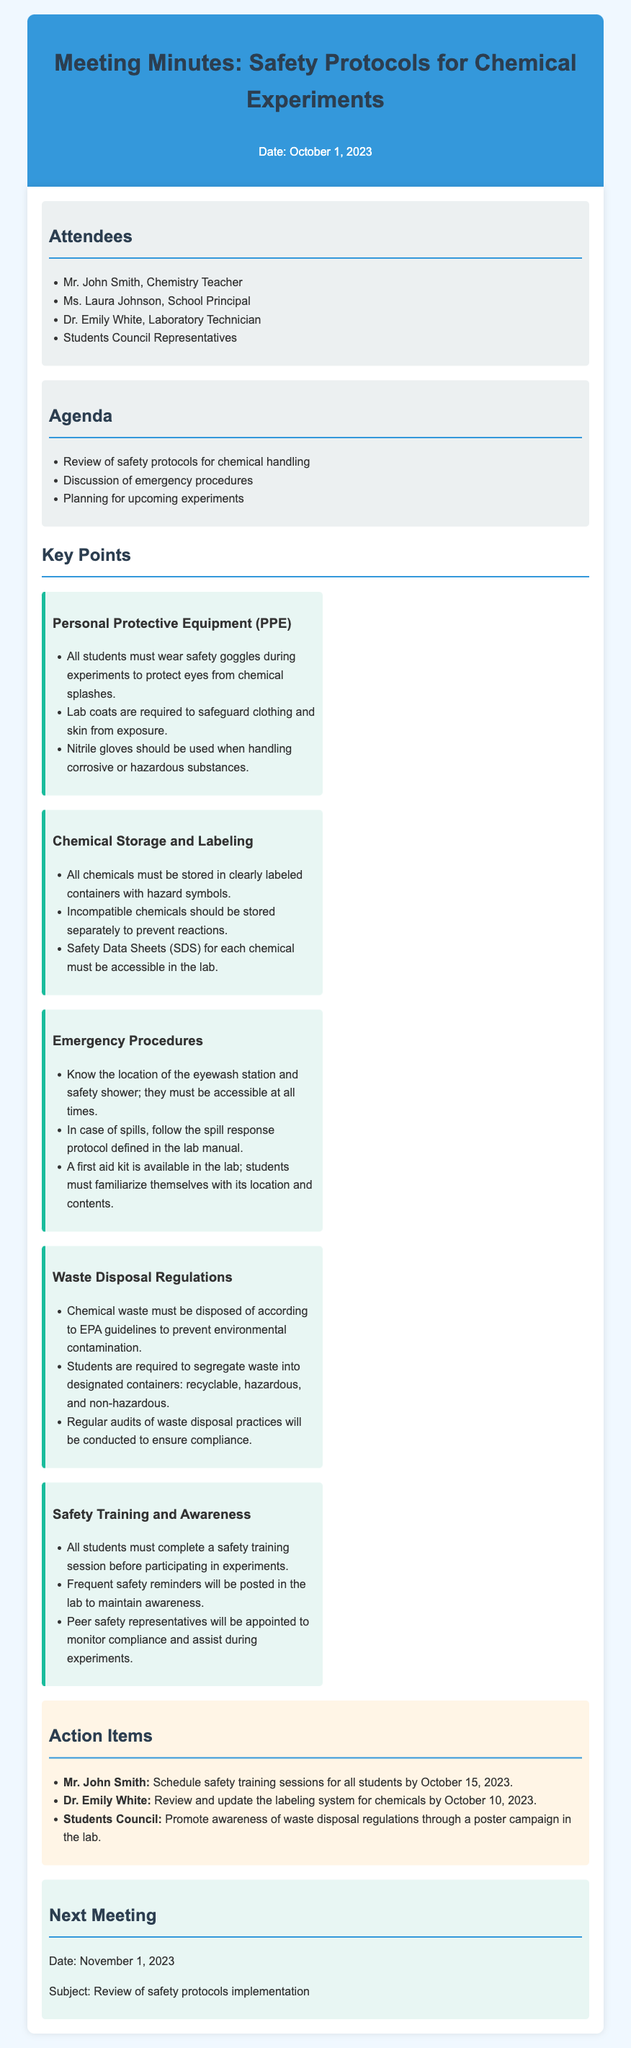What is the date of the meeting? The meeting date is stated in the document header.
Answer: October 1, 2023 Who is the chemistry teacher mentioned? Mr. John Smith is listed as the chemistry teacher in the attendees section.
Answer: Mr. John Smith What equipment must students wear during experiments? The key points outline the personal protective equipment needed.
Answer: Safety goggles What must be accessible in the lab according to the emergency procedures? The key points specify where students should know the location of during emergencies.
Answer: Eyewash station What are students required to complete before participating in experiments? The safety training and awareness section indicates what is mandatory for students.
Answer: Safety training session When is the next meeting scheduled? The next meeting date is mentioned towards the end of the document.
Answer: November 1, 2023 Who is responsible for reviewing the labeling system for chemicals? The action items list specifies who will update the labeling system.
Answer: Dr. Emily White What must chemical waste be disposed of according to? The waste disposal regulations section specifies the guidelines for disposal.
Answer: EPA guidelines What will the students council promote in the lab? The action items specify what the students council will do related to waste.
Answer: Awareness of waste disposal regulations 